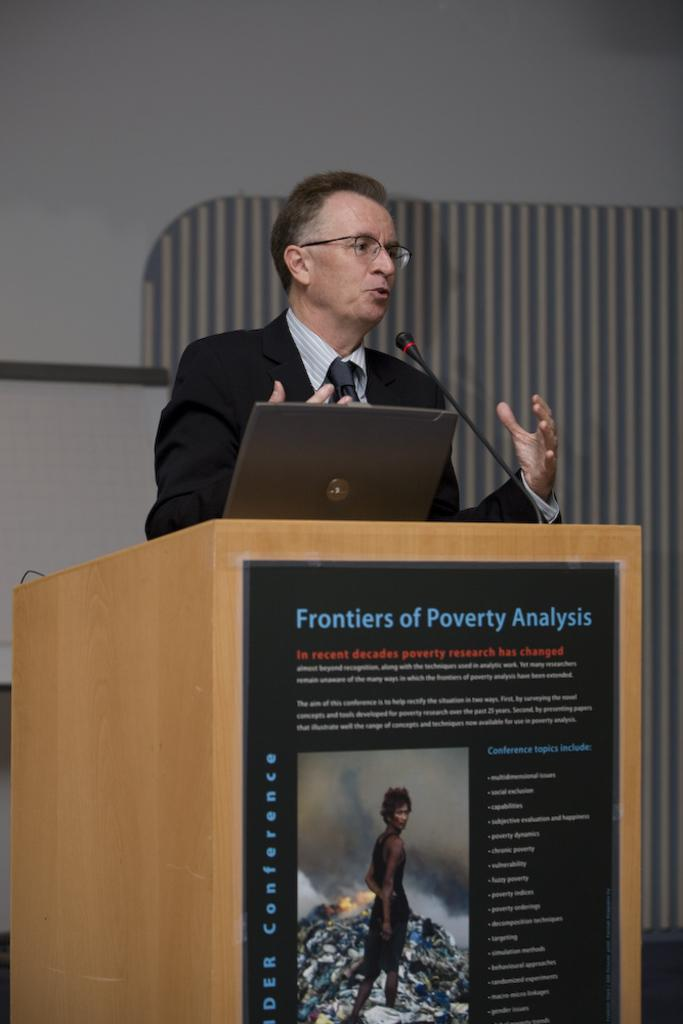<image>
Create a compact narrative representing the image presented. A man at a lectern that says Frontiers of Poverty Analysis 